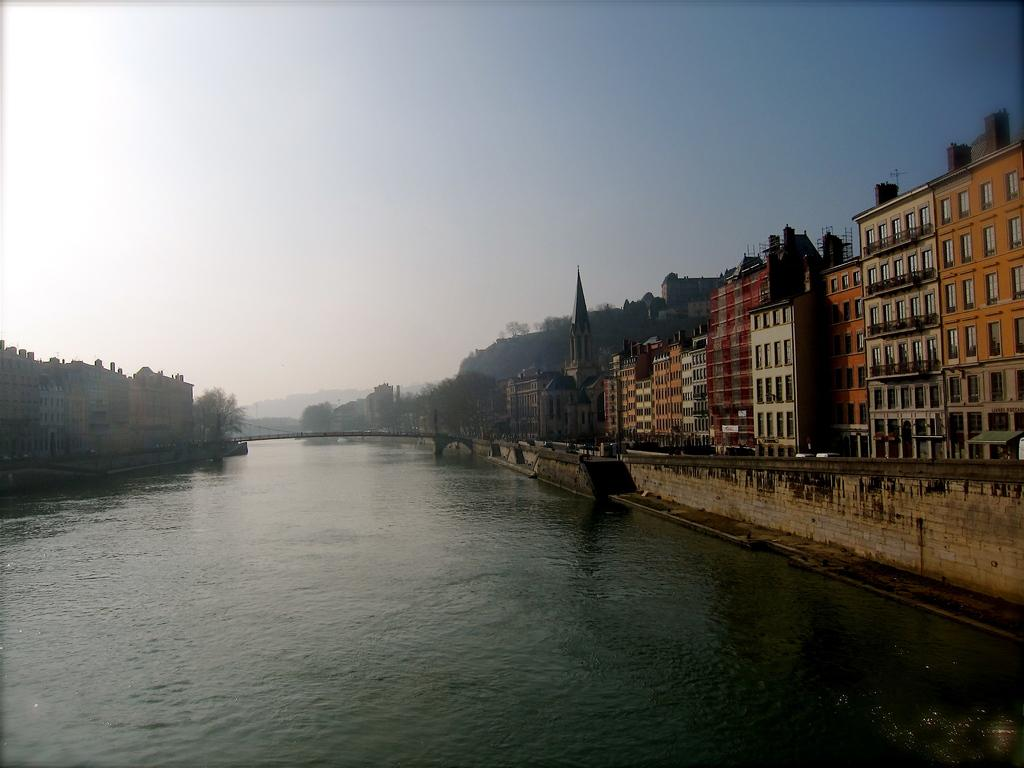What is located on either side of the path in the image? There is water on either side of the path in the image. What can be seen in the middle of the image? The path is visible in the image. What type of vegetation is present in the image? There are trees in the image. What type of structures are visible in the image? There are buildings with windows in the image. What material is used for some parts of the buildings? The buildings have glass elements. What can be seen in the distance in the image? There are hills visible in the background of the image. What is visible above the hills in the image? The sky is visible in the background of the image. Where is the library located in the image? There is no library mentioned or visible in the image. Can you describe the group of people standing near the water? There is no group of people mentioned or visible in the image. 